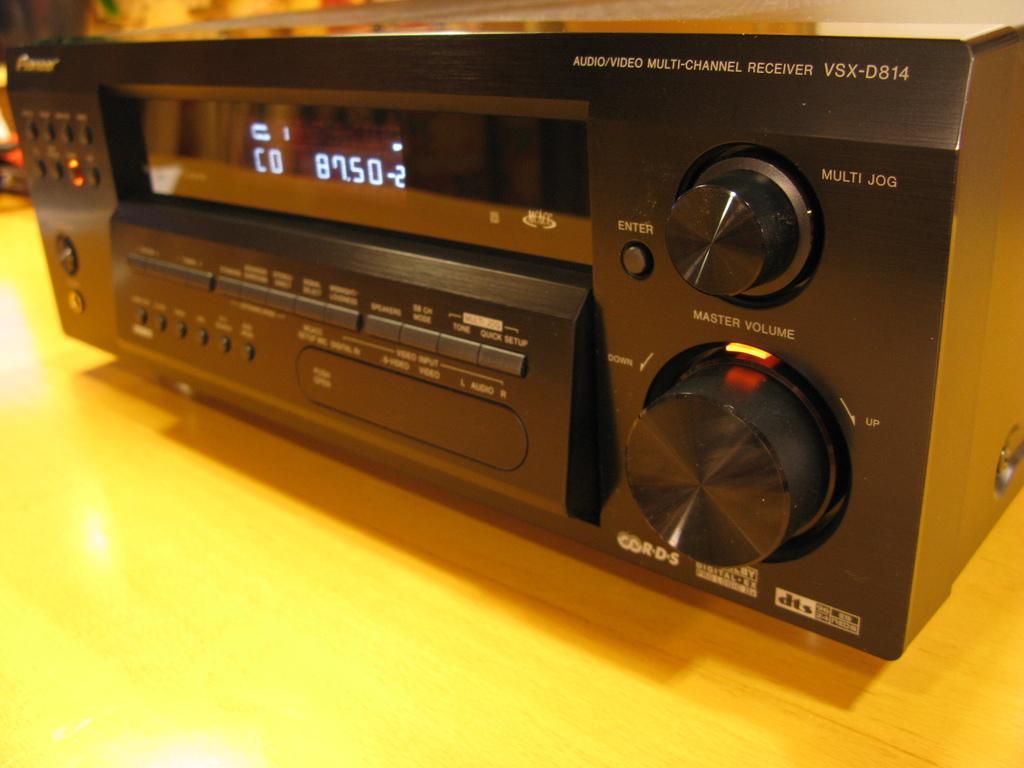Describe this image in one or two sentences. In this picture I can see there is a music player, it has a display screen, few buttons and it is placed on a wooden table. 